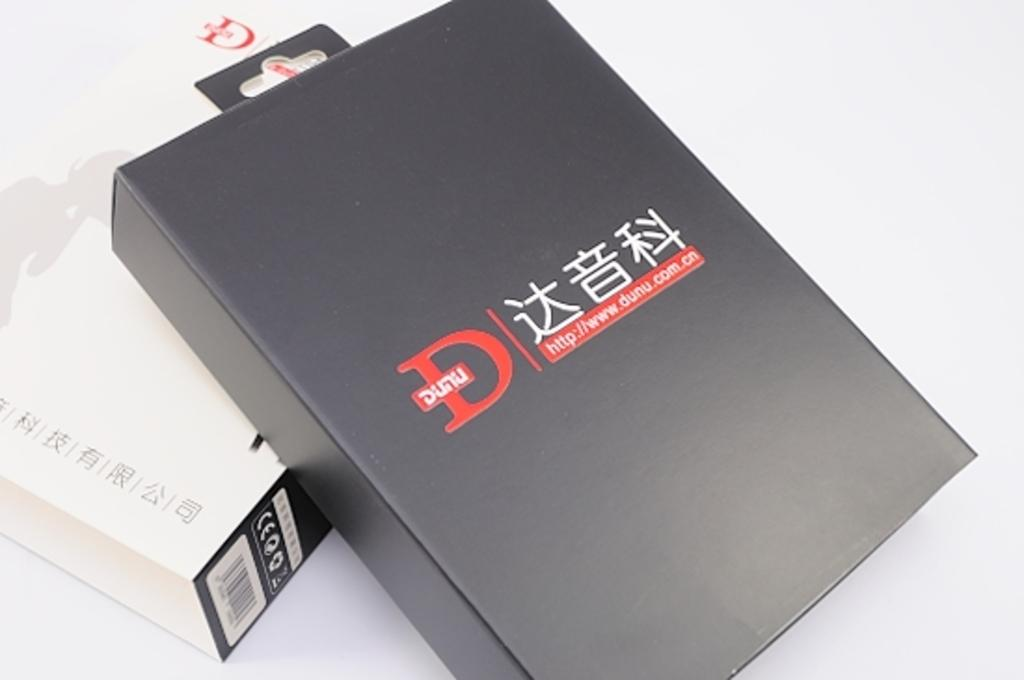<image>
Write a terse but informative summary of the picture. A black box has a large red D on it. 